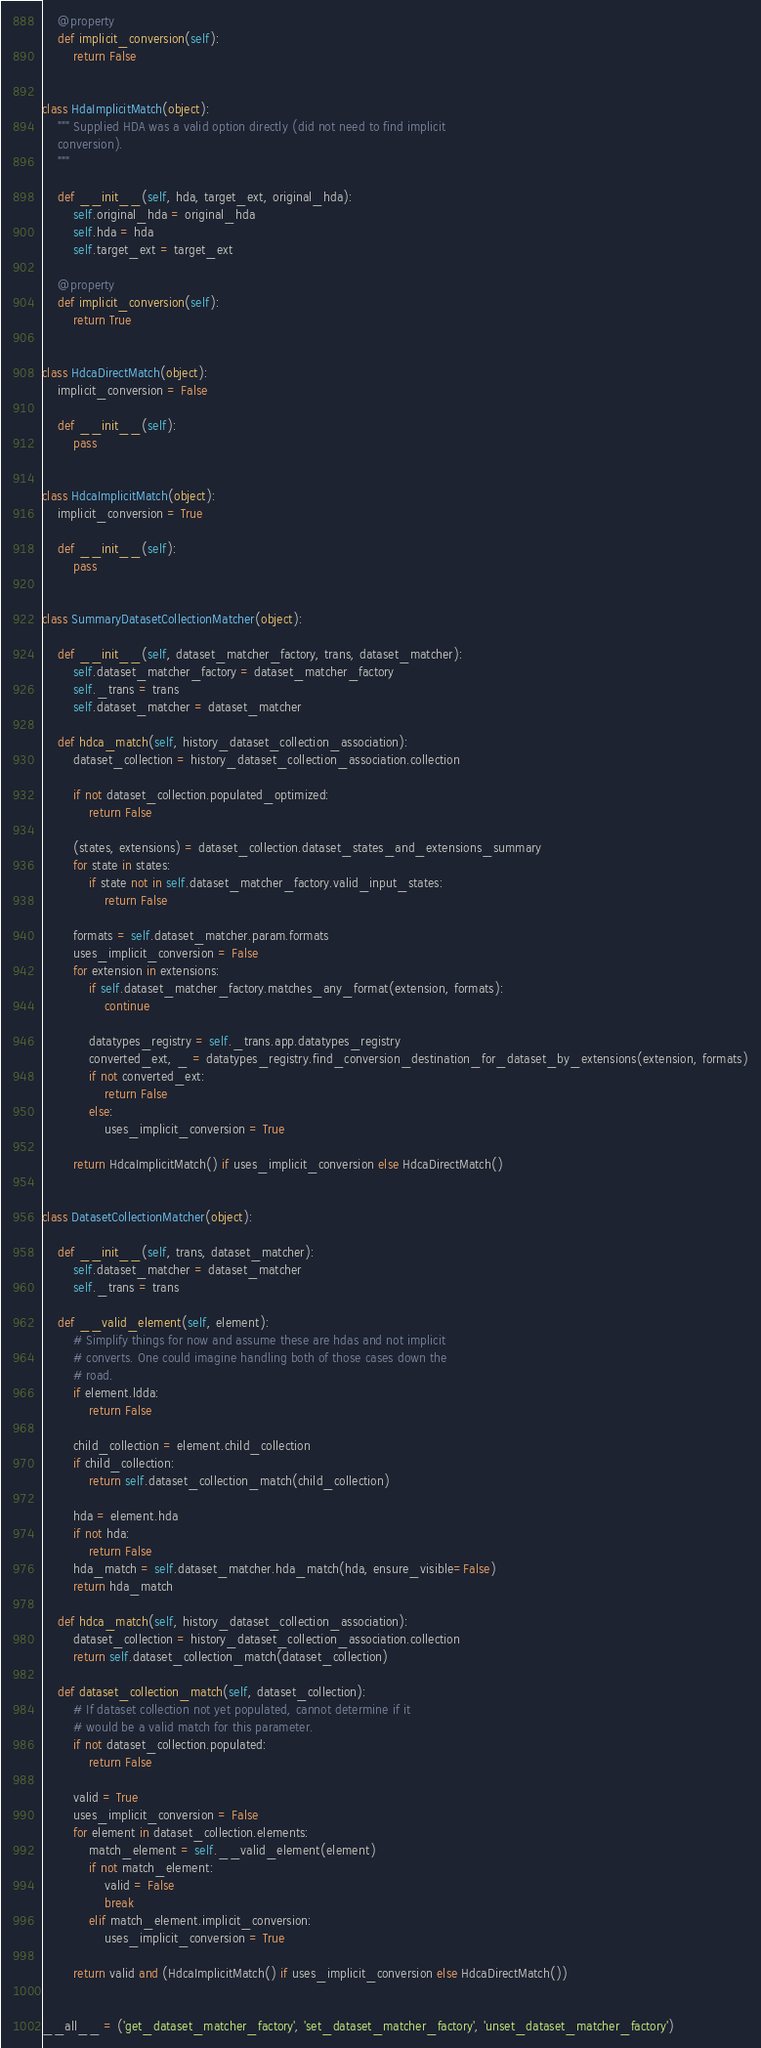Convert code to text. <code><loc_0><loc_0><loc_500><loc_500><_Python_>
    @property
    def implicit_conversion(self):
        return False


class HdaImplicitMatch(object):
    """ Supplied HDA was a valid option directly (did not need to find implicit
    conversion).
    """

    def __init__(self, hda, target_ext, original_hda):
        self.original_hda = original_hda
        self.hda = hda
        self.target_ext = target_ext

    @property
    def implicit_conversion(self):
        return True


class HdcaDirectMatch(object):
    implicit_conversion = False

    def __init__(self):
        pass


class HdcaImplicitMatch(object):
    implicit_conversion = True

    def __init__(self):
        pass


class SummaryDatasetCollectionMatcher(object):

    def __init__(self, dataset_matcher_factory, trans, dataset_matcher):
        self.dataset_matcher_factory = dataset_matcher_factory
        self._trans = trans
        self.dataset_matcher = dataset_matcher

    def hdca_match(self, history_dataset_collection_association):
        dataset_collection = history_dataset_collection_association.collection

        if not dataset_collection.populated_optimized:
            return False

        (states, extensions) = dataset_collection.dataset_states_and_extensions_summary
        for state in states:
            if state not in self.dataset_matcher_factory.valid_input_states:
                return False

        formats = self.dataset_matcher.param.formats
        uses_implicit_conversion = False
        for extension in extensions:
            if self.dataset_matcher_factory.matches_any_format(extension, formats):
                continue

            datatypes_registry = self._trans.app.datatypes_registry
            converted_ext, _ = datatypes_registry.find_conversion_destination_for_dataset_by_extensions(extension, formats)
            if not converted_ext:
                return False
            else:
                uses_implicit_conversion = True

        return HdcaImplicitMatch() if uses_implicit_conversion else HdcaDirectMatch()


class DatasetCollectionMatcher(object):

    def __init__(self, trans, dataset_matcher):
        self.dataset_matcher = dataset_matcher
        self._trans = trans

    def __valid_element(self, element):
        # Simplify things for now and assume these are hdas and not implicit
        # converts. One could imagine handling both of those cases down the
        # road.
        if element.ldda:
            return False

        child_collection = element.child_collection
        if child_collection:
            return self.dataset_collection_match(child_collection)

        hda = element.hda
        if not hda:
            return False
        hda_match = self.dataset_matcher.hda_match(hda, ensure_visible=False)
        return hda_match

    def hdca_match(self, history_dataset_collection_association):
        dataset_collection = history_dataset_collection_association.collection
        return self.dataset_collection_match(dataset_collection)

    def dataset_collection_match(self, dataset_collection):
        # If dataset collection not yet populated, cannot determine if it
        # would be a valid match for this parameter.
        if not dataset_collection.populated:
            return False

        valid = True
        uses_implicit_conversion = False
        for element in dataset_collection.elements:
            match_element = self.__valid_element(element)
            if not match_element:
                valid = False
                break
            elif match_element.implicit_conversion:
                uses_implicit_conversion = True

        return valid and (HdcaImplicitMatch() if uses_implicit_conversion else HdcaDirectMatch())


__all__ = ('get_dataset_matcher_factory', 'set_dataset_matcher_factory', 'unset_dataset_matcher_factory')
</code> 